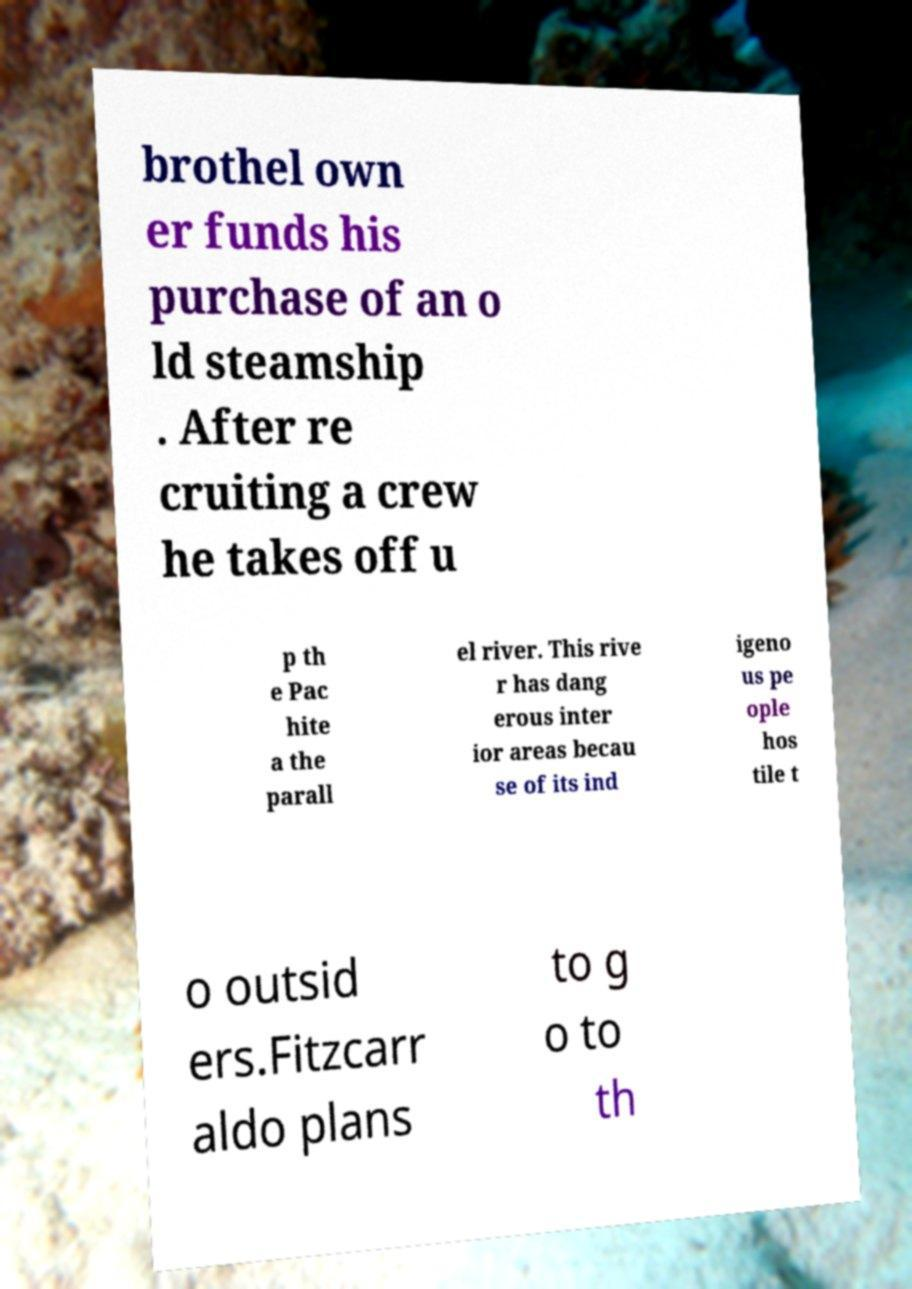I need the written content from this picture converted into text. Can you do that? brothel own er funds his purchase of an o ld steamship . After re cruiting a crew he takes off u p th e Pac hite a the parall el river. This rive r has dang erous inter ior areas becau se of its ind igeno us pe ople hos tile t o outsid ers.Fitzcarr aldo plans to g o to th 